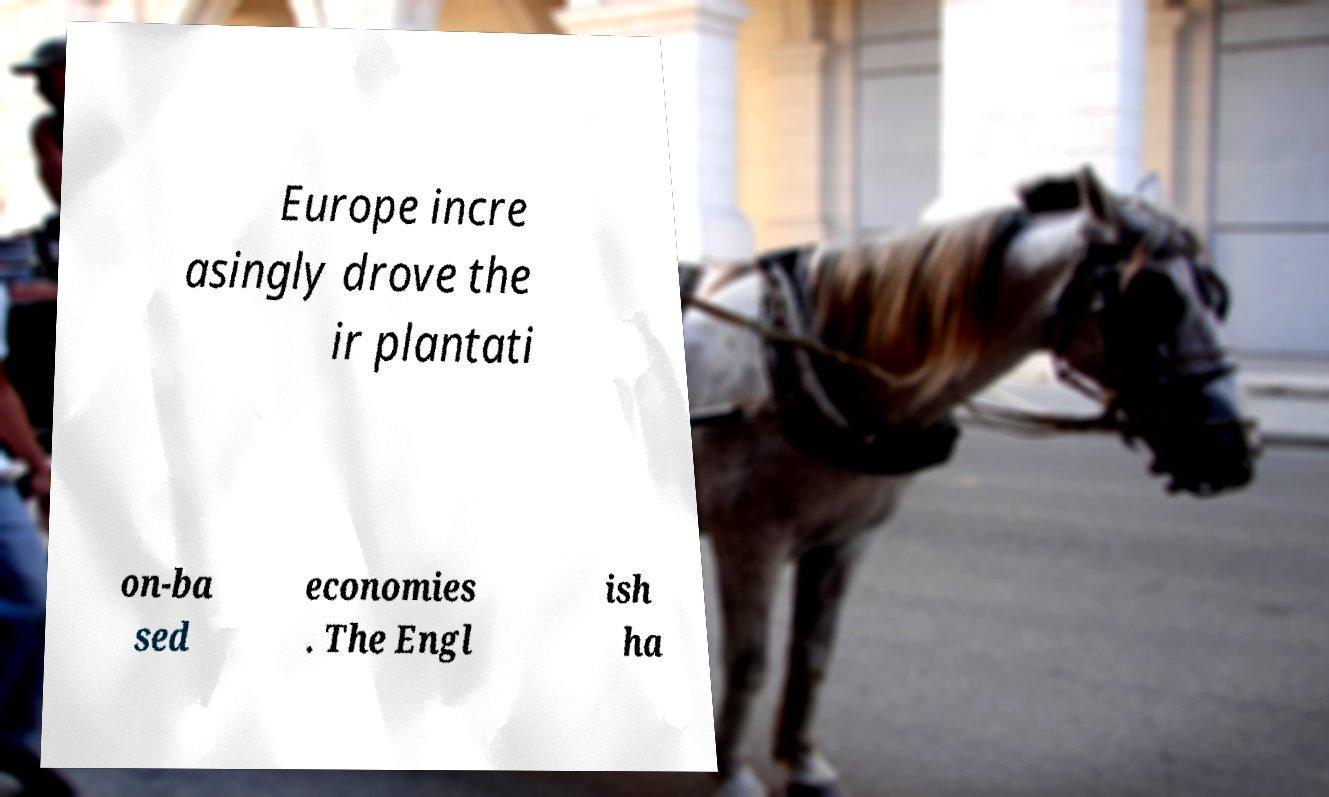Please identify and transcribe the text found in this image. Europe incre asingly drove the ir plantati on-ba sed economies . The Engl ish ha 